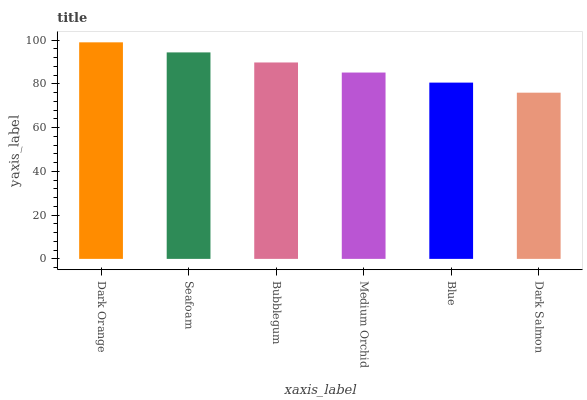Is Dark Salmon the minimum?
Answer yes or no. Yes. Is Dark Orange the maximum?
Answer yes or no. Yes. Is Seafoam the minimum?
Answer yes or no. No. Is Seafoam the maximum?
Answer yes or no. No. Is Dark Orange greater than Seafoam?
Answer yes or no. Yes. Is Seafoam less than Dark Orange?
Answer yes or no. Yes. Is Seafoam greater than Dark Orange?
Answer yes or no. No. Is Dark Orange less than Seafoam?
Answer yes or no. No. Is Bubblegum the high median?
Answer yes or no. Yes. Is Medium Orchid the low median?
Answer yes or no. Yes. Is Seafoam the high median?
Answer yes or no. No. Is Seafoam the low median?
Answer yes or no. No. 